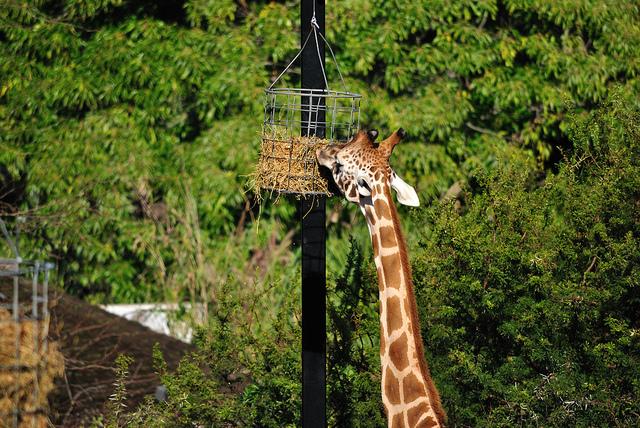Is the feed easily accessible for a pig?
Short answer required. No. What color are the leaves?
Short answer required. Green. Is the giraffe looking at the camera?
Concise answer only. No. What are the giraffes eating?
Short answer required. Hay. What is the giraffe eating?
Quick response, please. Hay. Is this giraffe in the wild?
Keep it brief. No. How many giraffes are facing the camera?
Short answer required. 0. 